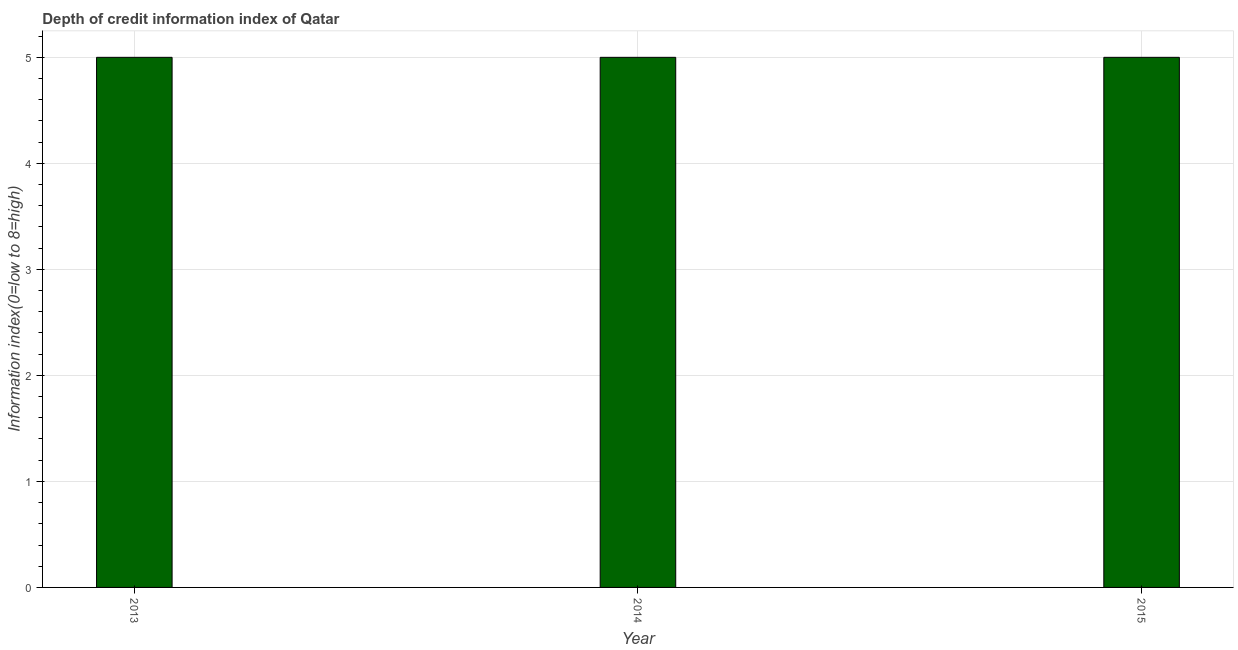Does the graph contain any zero values?
Provide a succinct answer. No. Does the graph contain grids?
Offer a very short reply. Yes. What is the title of the graph?
Provide a short and direct response. Depth of credit information index of Qatar. What is the label or title of the X-axis?
Offer a very short reply. Year. What is the label or title of the Y-axis?
Provide a short and direct response. Information index(0=low to 8=high). Across all years, what is the minimum depth of credit information index?
Make the answer very short. 5. What is the sum of the depth of credit information index?
Ensure brevity in your answer.  15. What is the difference between the depth of credit information index in 2014 and 2015?
Ensure brevity in your answer.  0. In how many years, is the depth of credit information index greater than 1.2 ?
Ensure brevity in your answer.  3. What is the ratio of the depth of credit information index in 2014 to that in 2015?
Ensure brevity in your answer.  1. What is the difference between two consecutive major ticks on the Y-axis?
Your answer should be very brief. 1. Are the values on the major ticks of Y-axis written in scientific E-notation?
Your response must be concise. No. What is the Information index(0=low to 8=high) of 2014?
Keep it short and to the point. 5. What is the Information index(0=low to 8=high) of 2015?
Provide a succinct answer. 5. What is the difference between the Information index(0=low to 8=high) in 2013 and 2014?
Make the answer very short. 0. What is the ratio of the Information index(0=low to 8=high) in 2013 to that in 2015?
Provide a succinct answer. 1. 